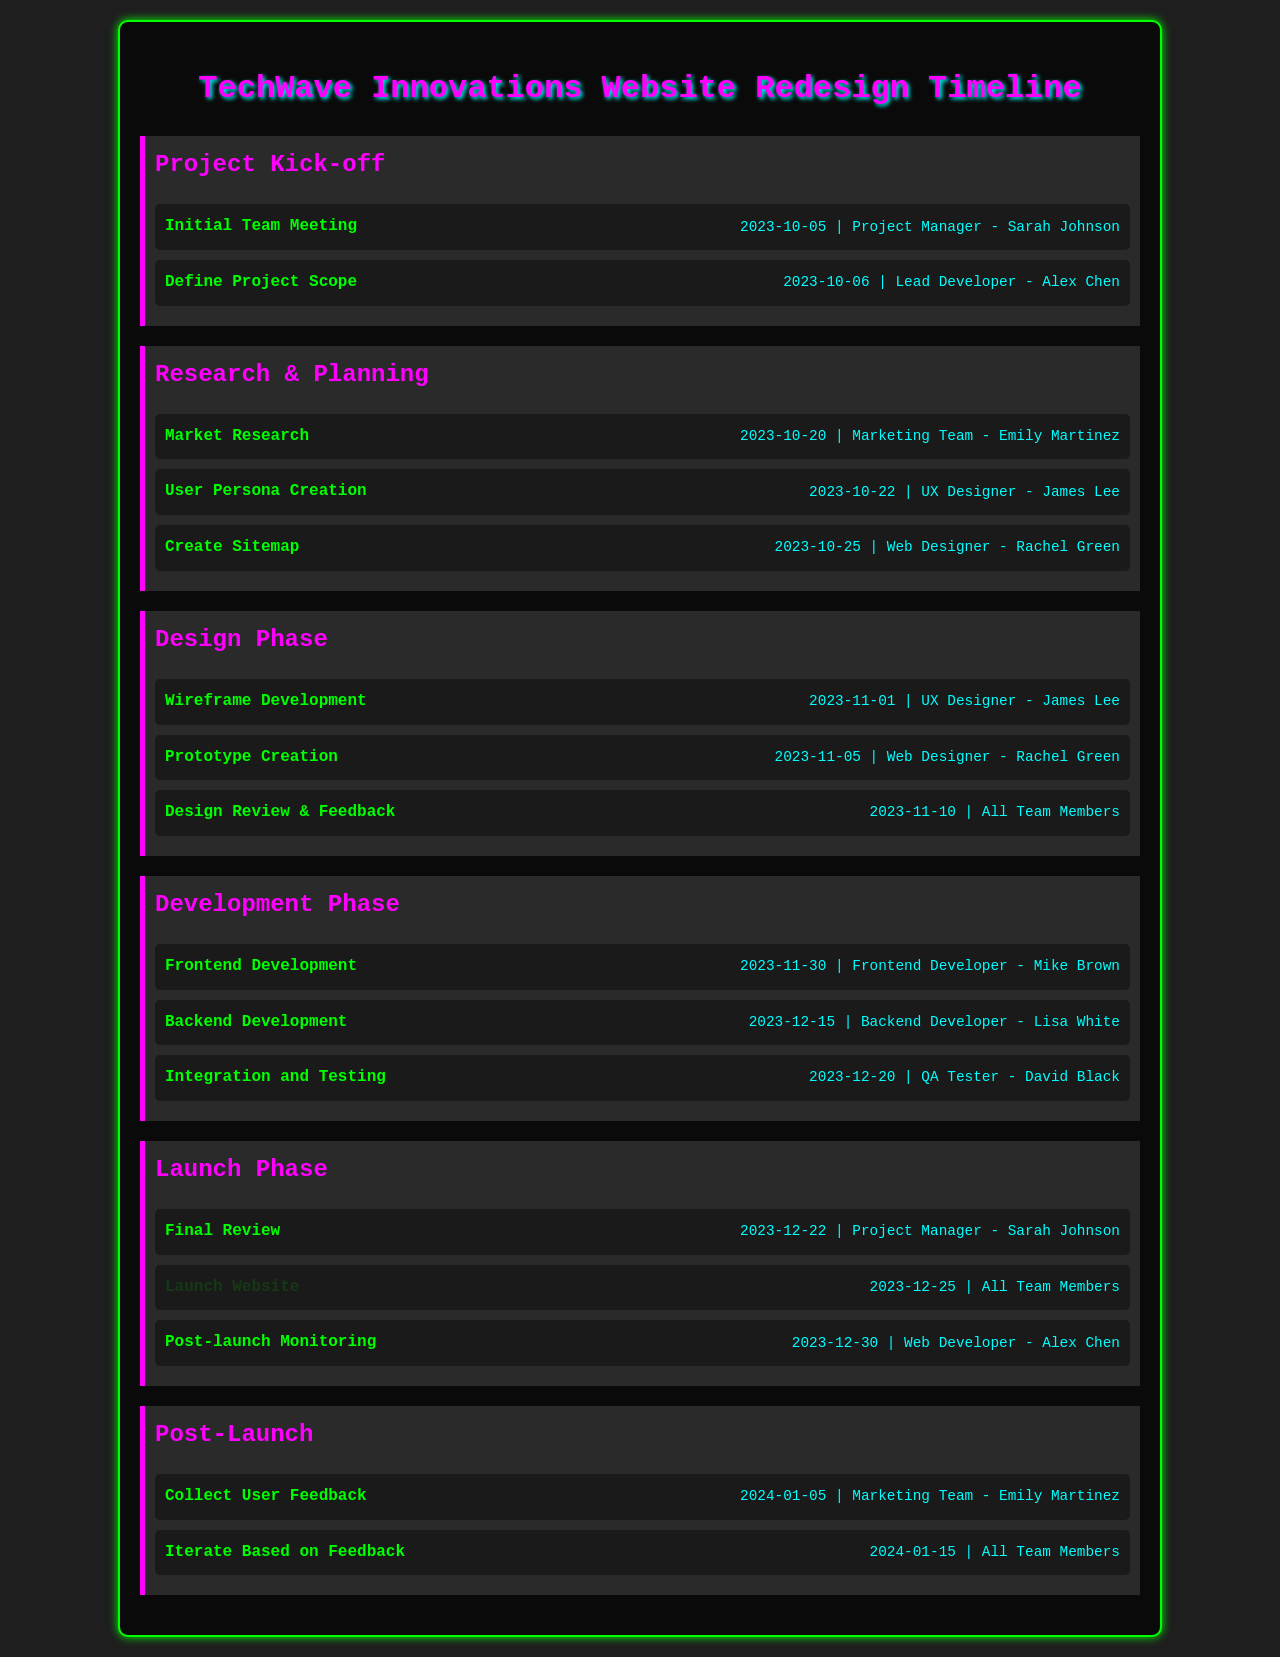What is the deadline for the Initial Team Meeting? The deadline for the Initial Team Meeting is provided in the document as the task date.
Answer: 2023-10-05 Who is responsible for the Backend Development? The document specifies the responsible team member for the Backend Development task.
Answer: Lisa White What task follows the Create Sitemap in the schedule? The document lists tasks in sequential order under each milestone, showing what comes next.
Answer: Wireframe Development Which phase includes the Design Review & Feedback? The phases in the document are clearly outlined, and this task is located within a specific phase.
Answer: Design Phase What is the launch date for the website? The launch date is specified in the timeline as part of the Launch Phase tasks.
Answer: 2023-12-25 When is the User Persona Creation scheduled? The scheduled date for User Persona Creation is detailed under the Research & Planning milestone.
Answer: 2023-10-22 Who needs to collect User Feedback? The document states which team member is responsible for collecting user feedback after the launch.
Answer: Emily Martinez How many tasks are listed under the Development Phase? The document can be referenced for counting the tasks under the Development Phase.
Answer: 3 